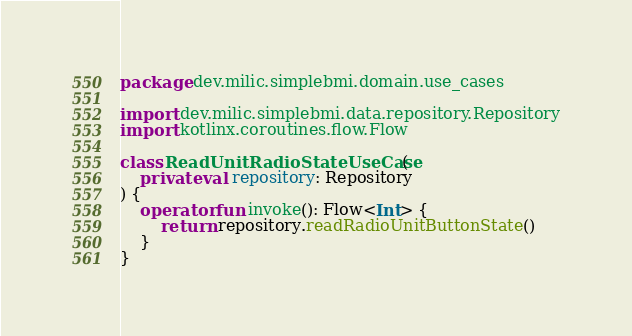<code> <loc_0><loc_0><loc_500><loc_500><_Kotlin_>package dev.milic.simplebmi.domain.use_cases

import dev.milic.simplebmi.data.repository.Repository
import kotlinx.coroutines.flow.Flow

class ReadUnitRadioStateUseCase(
    private val repository: Repository
) {
    operator fun invoke(): Flow<Int> {
        return repository.readRadioUnitButtonState()
    }
}</code> 